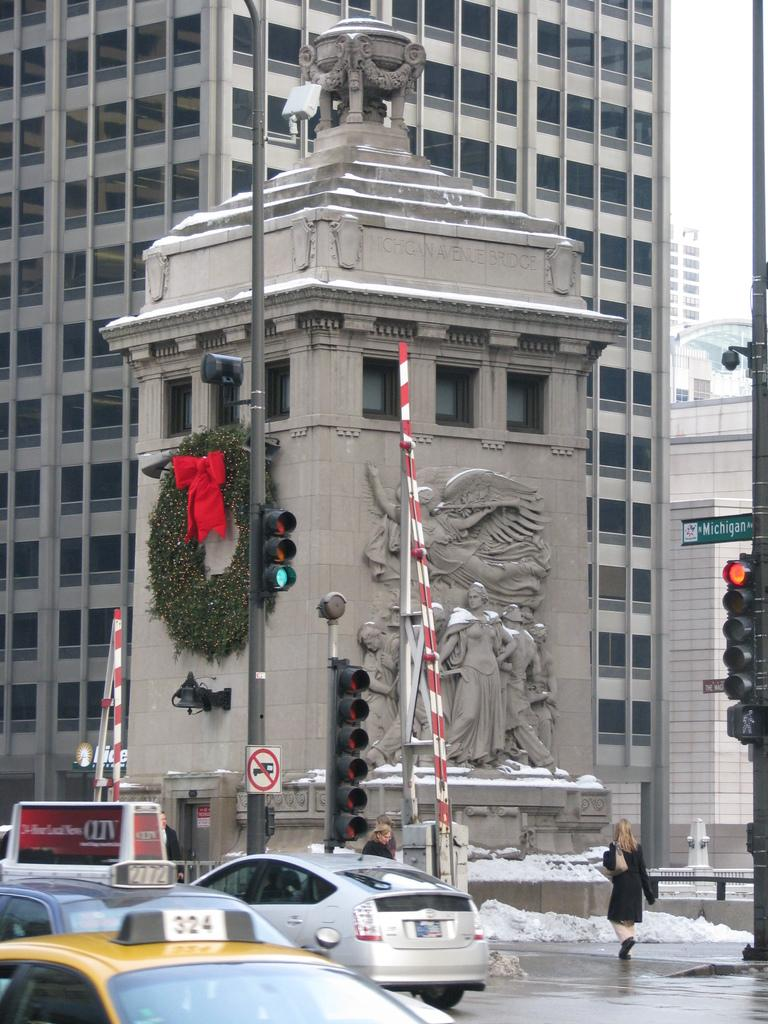What type of structures can be seen in the image? There are buildings in the image. How many people are present in the image? There are three persons in the image. What artistic elements are present in the image? There are sculptures in the image. What mode of transportation can be seen in the image? There are vehicles in the image. What type of traffic control devices are present in the image? There are signal lights in the image. What type of vertical structures are present in the image? There are poles in the image. What type of signage is present in the image? There are name boards in the image. What part of the natural environment is visible in the image? The sky is visible in the image. What type of stamp can be seen on the buildings in the image? There is no stamp present on the buildings in the image. What is the level of interest in the sculptures among the three persons in the image? The level of interest in the sculptures among the three persons cannot be determined from the image. 